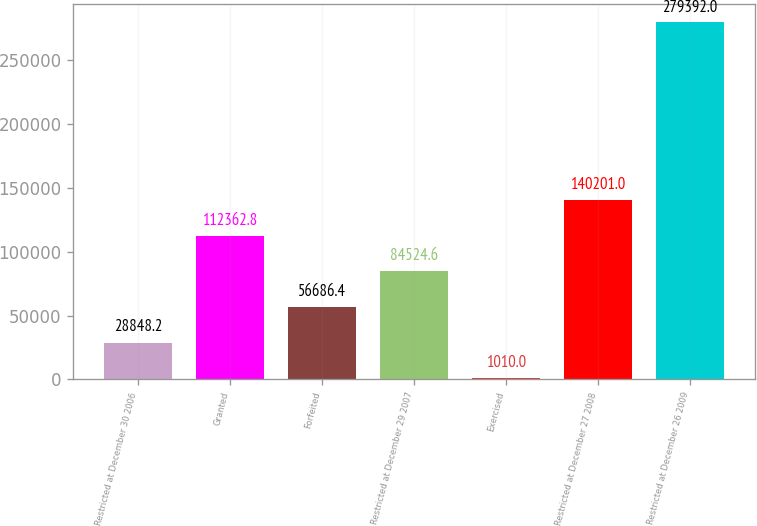Convert chart to OTSL. <chart><loc_0><loc_0><loc_500><loc_500><bar_chart><fcel>Restricted at December 30 2006<fcel>Granted<fcel>Forfeited<fcel>Restricted at December 29 2007<fcel>Exercised<fcel>Restricted at December 27 2008<fcel>Restricted at December 26 2009<nl><fcel>28848.2<fcel>112363<fcel>56686.4<fcel>84524.6<fcel>1010<fcel>140201<fcel>279392<nl></chart> 